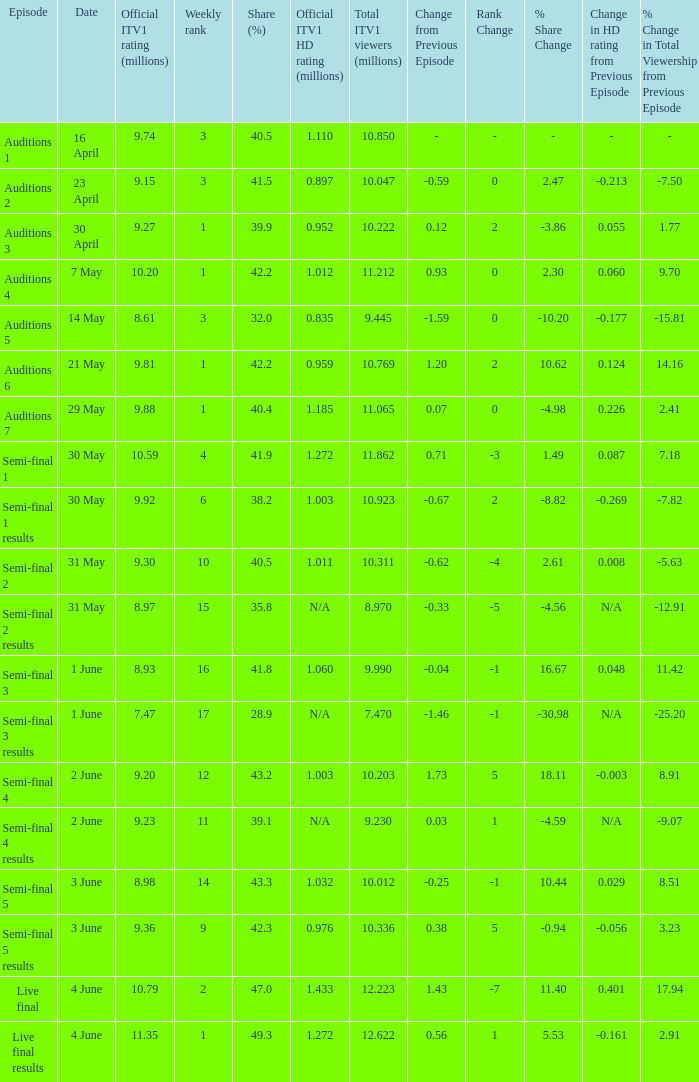Could you help me parse every detail presented in this table? {'header': ['Episode', 'Date', 'Official ITV1 rating (millions)', 'Weekly rank', 'Share (%)', 'Official ITV1 HD rating (millions)', 'Total ITV1 viewers (millions)', 'Change from Previous Episode', 'Rank Change', '% Share Change', 'Change in HD rating from Previous Episode', '% Change in Total Viewership from Previous Episode'], 'rows': [['Auditions 1', '16 April', '9.74', '3', '40.5', '1.110', '10.850', '-', '-', '-', '-', '-'], ['Auditions 2', '23 April', '9.15', '3', '41.5', '0.897', '10.047', '-0.59', '0', '2.47', '-0.213', '-7.50'], ['Auditions 3', '30 April', '9.27', '1', '39.9', '0.952', '10.222', '0.12', '2', '-3.86', '0.055', '1.77'], ['Auditions 4', '7 May', '10.20', '1', '42.2', '1.012', '11.212', '0.93', '0', '2.30', '0.060', '9.70'], ['Auditions 5', '14 May', '8.61', '3', '32.0', '0.835', '9.445', '-1.59', '0', '-10.20', '-0.177', '-15.81'], ['Auditions 6', '21 May', '9.81', '1', '42.2', '0.959', '10.769', '1.20', '2', '10.62', '0.124', '14.16'], ['Auditions 7', '29 May', '9.88', '1', '40.4', '1.185', '11.065', '0.07', '0', '-4.98', '0.226', '2.41'], ['Semi-final 1', '30 May', '10.59', '4', '41.9', '1.272', '11.862', '0.71', '-3', '1.49', '0.087', '7.18'], ['Semi-final 1 results', '30 May', '9.92', '6', '38.2', '1.003', '10.923', '-0.67', '2', '-8.82', '-0.269', '-7.82'], ['Semi-final 2', '31 May', '9.30', '10', '40.5', '1.011', '10.311', '-0.62', '-4', '2.61', '0.008', '-5.63'], ['Semi-final 2 results', '31 May', '8.97', '15', '35.8', 'N/A', '8.970', '-0.33', '-5', '-4.56', 'N/A', '-12.91'], ['Semi-final 3', '1 June', '8.93', '16', '41.8', '1.060', '9.990', '-0.04', '-1', '16.67', '0.048', '11.42'], ['Semi-final 3 results', '1 June', '7.47', '17', '28.9', 'N/A', '7.470', '-1.46', '-1', '-30.98', 'N/A', '-25.20'], ['Semi-final 4', '2 June', '9.20', '12', '43.2', '1.003', '10.203', '1.73', '5', '18.11', '-0.003', '8.91'], ['Semi-final 4 results', '2 June', '9.23', '11', '39.1', 'N/A', '9.230', '0.03', '1', '-4.59', 'N/A', '-9.07'], ['Semi-final 5', '3 June', '8.98', '14', '43.3', '1.032', '10.012', '-0.25', '-1', '10.44', '0.029', '8.51'], ['Semi-final 5 results', '3 June', '9.36', '9', '42.3', '0.976', '10.336', '0.38', '5', '-0.94', '-0.056', '3.23'], ['Live final', '4 June', '10.79', '2', '47.0', '1.433', '12.223', '1.43', '-7', '11.40', '0.401', '17.94'], ['Live final results', '4 June', '11.35', '1', '49.3', '1.272', '12.622', '0.56', '1', '5.53', '-0.161', '2.91']]} 98 million? 1.032. 